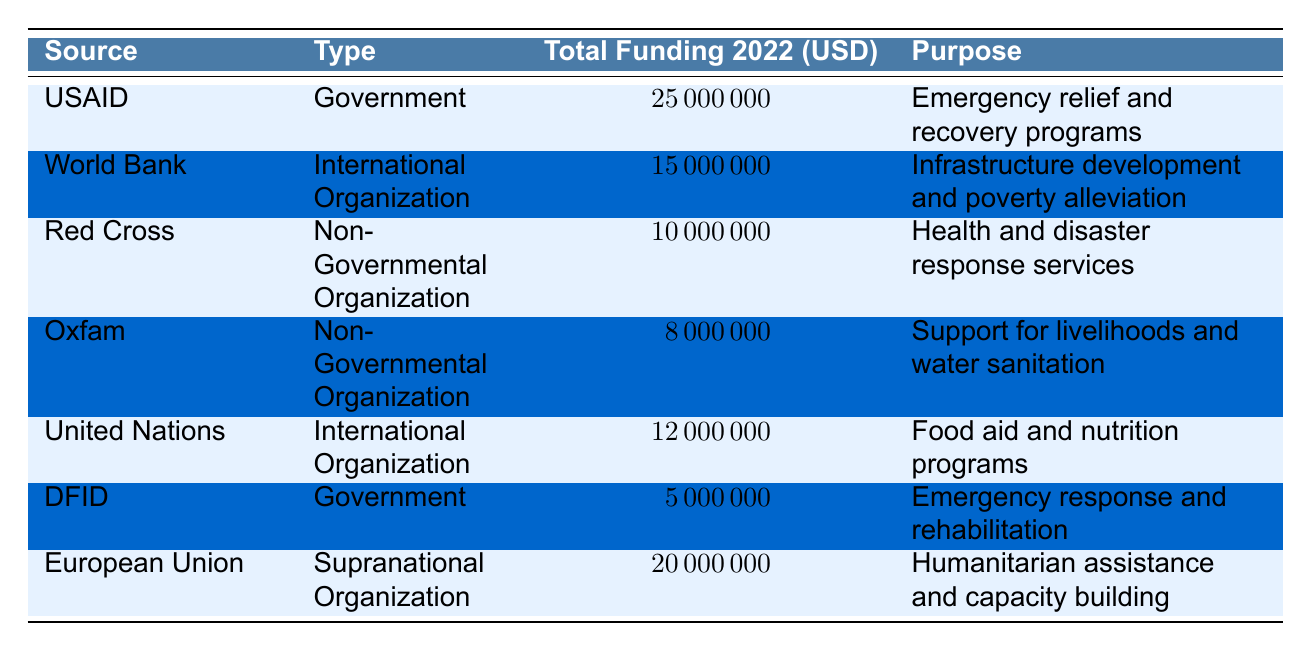What is the total funding provided by USAID in 2022? The table lists the total funding for each source. For USAID, the Total Funding 2022 is directly stated as 25000000 USD.
Answer: 25000000 USD What is the purpose of the funding from the Red Cross? Looking at the table, the purpose associated with the Red Cross funding is stated as "Health and disaster response services".
Answer: Health and disaster response services Which organization has the smallest funding amount and what is that amount? By inspecting the Total Funding column, it is evident that DFID has the smallest funding amount of 5000000 USD.
Answer: 5000000 USD How much more funding does the European Union provide compared to Oxfam? The Total Funding for the European Union is 20000000 USD and for Oxfam, it is 8000000 USD. The difference is calculated as 20000000 - 8000000 = 12000000 USD.
Answer: 12000000 USD Is the funding from the United Nations greater than that from the World Bank? The Total Funding from the United Nations is 12000000 USD while that from the World Bank is 15000000 USD. Since 12000000 is less than 15000000, the answer is no.
Answer: No What is the total funding from all the listed Government sources? The government sources listed are USAID (25000000 USD) and DFID (5000000 USD). The sum is calculated as 25000000 + 5000000 = 30000000 USD.
Answer: 30000000 USD Does the Red Cross contribute more funding than the United Nations? The Total Funding from the Red Cross is 10000000 USD while that from the United Nations is 12000000 USD. Since 10000000 is less than 12000000, the answer is no.
Answer: No What proportion of the total funding for 2022 is provided by Government sources? The total funding from Government sources (USAID and DFID) is 30000000 USD. The total funding from all sources is 25000000 + 15000000 + 10000000 + 8000000 + 12000000 + 5000000 + 20000000 = 103000000 USD. The proportion is computed as (30000000 / 103000000) * 100 ≈ 29.13%.
Answer: Approximately 29.13% What is the average funding provided by Non-Governmental Organizations? The Non-Governmental Organizations listed are Red Cross (10000000 USD) and Oxfam (8000000 USD). The average is calculated as (10000000 + 8000000) / 2 = 9000000 USD.
Answer: 9000000 USD 